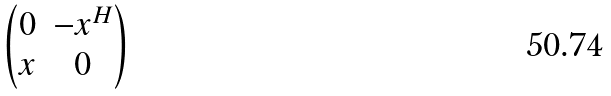<formula> <loc_0><loc_0><loc_500><loc_500>\begin{pmatrix} 0 & - x ^ { H } \\ x & 0 \end{pmatrix}</formula> 